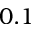<formula> <loc_0><loc_0><loc_500><loc_500>0 . 1</formula> 